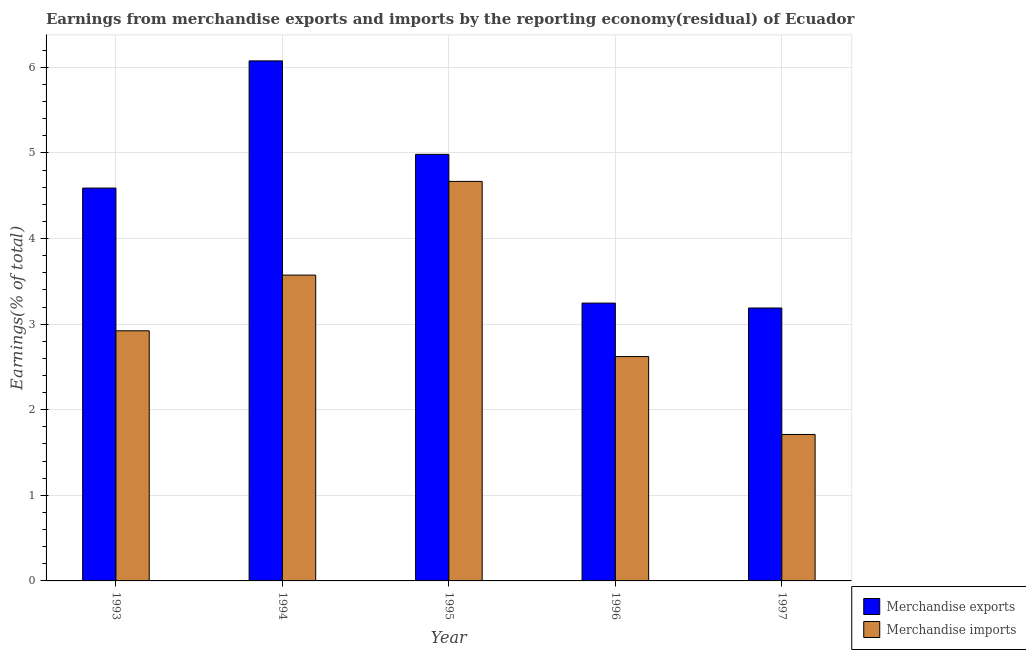How many different coloured bars are there?
Make the answer very short. 2. How many groups of bars are there?
Provide a short and direct response. 5. Are the number of bars on each tick of the X-axis equal?
Provide a succinct answer. Yes. How many bars are there on the 2nd tick from the left?
Offer a terse response. 2. What is the label of the 5th group of bars from the left?
Your response must be concise. 1997. What is the earnings from merchandise exports in 1993?
Offer a very short reply. 4.59. Across all years, what is the maximum earnings from merchandise exports?
Provide a short and direct response. 6.08. Across all years, what is the minimum earnings from merchandise exports?
Offer a terse response. 3.19. In which year was the earnings from merchandise exports minimum?
Your answer should be compact. 1997. What is the total earnings from merchandise imports in the graph?
Provide a succinct answer. 15.49. What is the difference between the earnings from merchandise exports in 1993 and that in 1996?
Provide a succinct answer. 1.34. What is the difference between the earnings from merchandise exports in 1994 and the earnings from merchandise imports in 1993?
Give a very brief answer. 1.49. What is the average earnings from merchandise imports per year?
Ensure brevity in your answer.  3.1. In the year 1995, what is the difference between the earnings from merchandise exports and earnings from merchandise imports?
Your answer should be very brief. 0. In how many years, is the earnings from merchandise exports greater than 0.2 %?
Offer a terse response. 5. What is the ratio of the earnings from merchandise exports in 1993 to that in 1995?
Make the answer very short. 0.92. Is the earnings from merchandise exports in 1995 less than that in 1996?
Provide a succinct answer. No. What is the difference between the highest and the second highest earnings from merchandise imports?
Make the answer very short. 1.09. What is the difference between the highest and the lowest earnings from merchandise exports?
Offer a terse response. 2.89. In how many years, is the earnings from merchandise imports greater than the average earnings from merchandise imports taken over all years?
Provide a short and direct response. 2. What does the 1st bar from the right in 1994 represents?
Provide a short and direct response. Merchandise imports. How many bars are there?
Your response must be concise. 10. What is the difference between two consecutive major ticks on the Y-axis?
Provide a short and direct response. 1. Where does the legend appear in the graph?
Provide a succinct answer. Bottom right. How many legend labels are there?
Keep it short and to the point. 2. What is the title of the graph?
Keep it short and to the point. Earnings from merchandise exports and imports by the reporting economy(residual) of Ecuador. Does "US$" appear as one of the legend labels in the graph?
Ensure brevity in your answer.  No. What is the label or title of the X-axis?
Offer a terse response. Year. What is the label or title of the Y-axis?
Provide a succinct answer. Earnings(% of total). What is the Earnings(% of total) of Merchandise exports in 1993?
Provide a short and direct response. 4.59. What is the Earnings(% of total) in Merchandise imports in 1993?
Ensure brevity in your answer.  2.92. What is the Earnings(% of total) in Merchandise exports in 1994?
Give a very brief answer. 6.08. What is the Earnings(% of total) in Merchandise imports in 1994?
Your answer should be very brief. 3.57. What is the Earnings(% of total) in Merchandise exports in 1995?
Your response must be concise. 4.98. What is the Earnings(% of total) in Merchandise imports in 1995?
Ensure brevity in your answer.  4.67. What is the Earnings(% of total) in Merchandise exports in 1996?
Give a very brief answer. 3.25. What is the Earnings(% of total) in Merchandise imports in 1996?
Make the answer very short. 2.62. What is the Earnings(% of total) in Merchandise exports in 1997?
Your answer should be very brief. 3.19. What is the Earnings(% of total) of Merchandise imports in 1997?
Keep it short and to the point. 1.71. Across all years, what is the maximum Earnings(% of total) of Merchandise exports?
Provide a short and direct response. 6.08. Across all years, what is the maximum Earnings(% of total) of Merchandise imports?
Offer a terse response. 4.67. Across all years, what is the minimum Earnings(% of total) of Merchandise exports?
Give a very brief answer. 3.19. Across all years, what is the minimum Earnings(% of total) in Merchandise imports?
Provide a short and direct response. 1.71. What is the total Earnings(% of total) of Merchandise exports in the graph?
Ensure brevity in your answer.  22.08. What is the total Earnings(% of total) in Merchandise imports in the graph?
Give a very brief answer. 15.49. What is the difference between the Earnings(% of total) of Merchandise exports in 1993 and that in 1994?
Keep it short and to the point. -1.49. What is the difference between the Earnings(% of total) of Merchandise imports in 1993 and that in 1994?
Offer a terse response. -0.65. What is the difference between the Earnings(% of total) in Merchandise exports in 1993 and that in 1995?
Ensure brevity in your answer.  -0.39. What is the difference between the Earnings(% of total) in Merchandise imports in 1993 and that in 1995?
Your response must be concise. -1.75. What is the difference between the Earnings(% of total) in Merchandise exports in 1993 and that in 1996?
Your response must be concise. 1.34. What is the difference between the Earnings(% of total) in Merchandise imports in 1993 and that in 1996?
Keep it short and to the point. 0.3. What is the difference between the Earnings(% of total) of Merchandise exports in 1993 and that in 1997?
Provide a short and direct response. 1.4. What is the difference between the Earnings(% of total) in Merchandise imports in 1993 and that in 1997?
Make the answer very short. 1.21. What is the difference between the Earnings(% of total) of Merchandise exports in 1994 and that in 1995?
Offer a very short reply. 1.09. What is the difference between the Earnings(% of total) of Merchandise imports in 1994 and that in 1995?
Ensure brevity in your answer.  -1.09. What is the difference between the Earnings(% of total) of Merchandise exports in 1994 and that in 1996?
Ensure brevity in your answer.  2.83. What is the difference between the Earnings(% of total) of Merchandise imports in 1994 and that in 1996?
Offer a very short reply. 0.95. What is the difference between the Earnings(% of total) in Merchandise exports in 1994 and that in 1997?
Offer a very short reply. 2.89. What is the difference between the Earnings(% of total) in Merchandise imports in 1994 and that in 1997?
Provide a short and direct response. 1.86. What is the difference between the Earnings(% of total) in Merchandise exports in 1995 and that in 1996?
Make the answer very short. 1.74. What is the difference between the Earnings(% of total) in Merchandise imports in 1995 and that in 1996?
Ensure brevity in your answer.  2.05. What is the difference between the Earnings(% of total) in Merchandise exports in 1995 and that in 1997?
Provide a short and direct response. 1.8. What is the difference between the Earnings(% of total) of Merchandise imports in 1995 and that in 1997?
Keep it short and to the point. 2.96. What is the difference between the Earnings(% of total) in Merchandise exports in 1996 and that in 1997?
Your answer should be compact. 0.06. What is the difference between the Earnings(% of total) in Merchandise imports in 1996 and that in 1997?
Provide a short and direct response. 0.91. What is the difference between the Earnings(% of total) in Merchandise exports in 1993 and the Earnings(% of total) in Merchandise imports in 1994?
Provide a short and direct response. 1.02. What is the difference between the Earnings(% of total) in Merchandise exports in 1993 and the Earnings(% of total) in Merchandise imports in 1995?
Your response must be concise. -0.08. What is the difference between the Earnings(% of total) in Merchandise exports in 1993 and the Earnings(% of total) in Merchandise imports in 1996?
Keep it short and to the point. 1.97. What is the difference between the Earnings(% of total) in Merchandise exports in 1993 and the Earnings(% of total) in Merchandise imports in 1997?
Ensure brevity in your answer.  2.88. What is the difference between the Earnings(% of total) in Merchandise exports in 1994 and the Earnings(% of total) in Merchandise imports in 1995?
Your answer should be compact. 1.41. What is the difference between the Earnings(% of total) in Merchandise exports in 1994 and the Earnings(% of total) in Merchandise imports in 1996?
Ensure brevity in your answer.  3.45. What is the difference between the Earnings(% of total) of Merchandise exports in 1994 and the Earnings(% of total) of Merchandise imports in 1997?
Give a very brief answer. 4.36. What is the difference between the Earnings(% of total) of Merchandise exports in 1995 and the Earnings(% of total) of Merchandise imports in 1996?
Your response must be concise. 2.36. What is the difference between the Earnings(% of total) of Merchandise exports in 1995 and the Earnings(% of total) of Merchandise imports in 1997?
Ensure brevity in your answer.  3.27. What is the difference between the Earnings(% of total) in Merchandise exports in 1996 and the Earnings(% of total) in Merchandise imports in 1997?
Offer a very short reply. 1.54. What is the average Earnings(% of total) in Merchandise exports per year?
Your response must be concise. 4.42. What is the average Earnings(% of total) in Merchandise imports per year?
Your answer should be compact. 3.1. In the year 1993, what is the difference between the Earnings(% of total) of Merchandise exports and Earnings(% of total) of Merchandise imports?
Make the answer very short. 1.67. In the year 1994, what is the difference between the Earnings(% of total) of Merchandise exports and Earnings(% of total) of Merchandise imports?
Your answer should be compact. 2.5. In the year 1995, what is the difference between the Earnings(% of total) of Merchandise exports and Earnings(% of total) of Merchandise imports?
Keep it short and to the point. 0.32. In the year 1996, what is the difference between the Earnings(% of total) of Merchandise exports and Earnings(% of total) of Merchandise imports?
Your response must be concise. 0.62. In the year 1997, what is the difference between the Earnings(% of total) in Merchandise exports and Earnings(% of total) in Merchandise imports?
Your answer should be very brief. 1.48. What is the ratio of the Earnings(% of total) of Merchandise exports in 1993 to that in 1994?
Offer a very short reply. 0.76. What is the ratio of the Earnings(% of total) of Merchandise imports in 1993 to that in 1994?
Keep it short and to the point. 0.82. What is the ratio of the Earnings(% of total) of Merchandise exports in 1993 to that in 1995?
Make the answer very short. 0.92. What is the ratio of the Earnings(% of total) of Merchandise imports in 1993 to that in 1995?
Provide a short and direct response. 0.63. What is the ratio of the Earnings(% of total) of Merchandise exports in 1993 to that in 1996?
Make the answer very short. 1.41. What is the ratio of the Earnings(% of total) in Merchandise imports in 1993 to that in 1996?
Keep it short and to the point. 1.11. What is the ratio of the Earnings(% of total) in Merchandise exports in 1993 to that in 1997?
Keep it short and to the point. 1.44. What is the ratio of the Earnings(% of total) of Merchandise imports in 1993 to that in 1997?
Provide a succinct answer. 1.71. What is the ratio of the Earnings(% of total) of Merchandise exports in 1994 to that in 1995?
Keep it short and to the point. 1.22. What is the ratio of the Earnings(% of total) in Merchandise imports in 1994 to that in 1995?
Your answer should be compact. 0.77. What is the ratio of the Earnings(% of total) in Merchandise exports in 1994 to that in 1996?
Make the answer very short. 1.87. What is the ratio of the Earnings(% of total) of Merchandise imports in 1994 to that in 1996?
Your response must be concise. 1.36. What is the ratio of the Earnings(% of total) of Merchandise exports in 1994 to that in 1997?
Provide a short and direct response. 1.91. What is the ratio of the Earnings(% of total) in Merchandise imports in 1994 to that in 1997?
Your response must be concise. 2.09. What is the ratio of the Earnings(% of total) in Merchandise exports in 1995 to that in 1996?
Offer a terse response. 1.54. What is the ratio of the Earnings(% of total) in Merchandise imports in 1995 to that in 1996?
Give a very brief answer. 1.78. What is the ratio of the Earnings(% of total) of Merchandise exports in 1995 to that in 1997?
Provide a succinct answer. 1.56. What is the ratio of the Earnings(% of total) of Merchandise imports in 1995 to that in 1997?
Your response must be concise. 2.73. What is the ratio of the Earnings(% of total) in Merchandise imports in 1996 to that in 1997?
Offer a terse response. 1.53. What is the difference between the highest and the second highest Earnings(% of total) of Merchandise exports?
Your answer should be very brief. 1.09. What is the difference between the highest and the second highest Earnings(% of total) in Merchandise imports?
Ensure brevity in your answer.  1.09. What is the difference between the highest and the lowest Earnings(% of total) in Merchandise exports?
Keep it short and to the point. 2.89. What is the difference between the highest and the lowest Earnings(% of total) in Merchandise imports?
Provide a short and direct response. 2.96. 